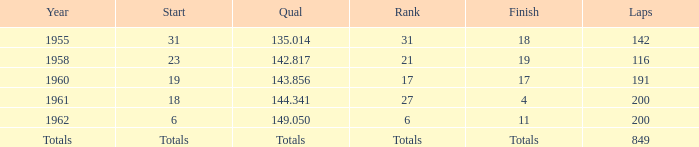I'm looking to parse the entire table for insights. Could you assist me with that? {'header': ['Year', 'Start', 'Qual', 'Rank', 'Finish', 'Laps'], 'rows': [['1955', '31', '135.014', '31', '18', '142'], ['1958', '23', '142.817', '21', '19', '116'], ['1960', '19', '143.856', '17', '17', '191'], ['1961', '18', '144.341', '27', '4', '200'], ['1962', '6', '149.050', '6', '11', '200'], ['Totals', 'Totals', 'Totals', 'Totals', 'Totals', '849']]} What year has a finish of 19? 1958.0. 